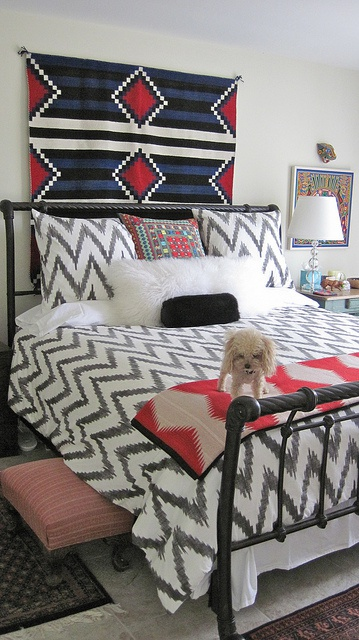Describe the objects in this image and their specific colors. I can see bed in darkgray, lightgray, gray, and black tones and dog in darkgray and gray tones in this image. 